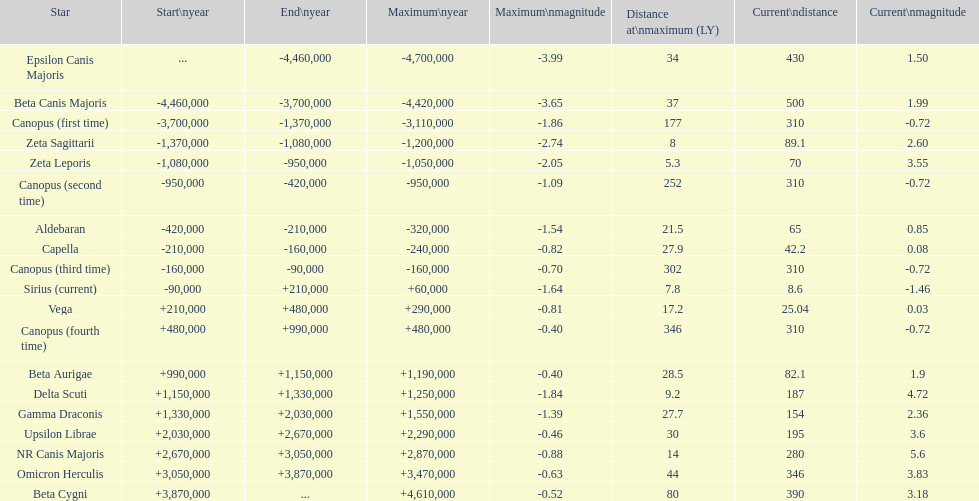What is the number of stars that have a maximum magnitude less than zero? 5. Would you be able to parse every entry in this table? {'header': ['Star', 'Start\\nyear', 'End\\nyear', 'Maximum\\nyear', 'Maximum\\nmagnitude', 'Distance at\\nmaximum (LY)', 'Current\\ndistance', 'Current\\nmagnitude'], 'rows': [['Epsilon Canis Majoris', '...', '-4,460,000', '-4,700,000', '-3.99', '34', '430', '1.50'], ['Beta Canis Majoris', '-4,460,000', '-3,700,000', '-4,420,000', '-3.65', '37', '500', '1.99'], ['Canopus (first time)', '-3,700,000', '-1,370,000', '-3,110,000', '-1.86', '177', '310', '-0.72'], ['Zeta Sagittarii', '-1,370,000', '-1,080,000', '-1,200,000', '-2.74', '8', '89.1', '2.60'], ['Zeta Leporis', '-1,080,000', '-950,000', '-1,050,000', '-2.05', '5.3', '70', '3.55'], ['Canopus (second time)', '-950,000', '-420,000', '-950,000', '-1.09', '252', '310', '-0.72'], ['Aldebaran', '-420,000', '-210,000', '-320,000', '-1.54', '21.5', '65', '0.85'], ['Capella', '-210,000', '-160,000', '-240,000', '-0.82', '27.9', '42.2', '0.08'], ['Canopus (third time)', '-160,000', '-90,000', '-160,000', '-0.70', '302', '310', '-0.72'], ['Sirius (current)', '-90,000', '+210,000', '+60,000', '-1.64', '7.8', '8.6', '-1.46'], ['Vega', '+210,000', '+480,000', '+290,000', '-0.81', '17.2', '25.04', '0.03'], ['Canopus (fourth time)', '+480,000', '+990,000', '+480,000', '-0.40', '346', '310', '-0.72'], ['Beta Aurigae', '+990,000', '+1,150,000', '+1,190,000', '-0.40', '28.5', '82.1', '1.9'], ['Delta Scuti', '+1,150,000', '+1,330,000', '+1,250,000', '-1.84', '9.2', '187', '4.72'], ['Gamma Draconis', '+1,330,000', '+2,030,000', '+1,550,000', '-1.39', '27.7', '154', '2.36'], ['Upsilon Librae', '+2,030,000', '+2,670,000', '+2,290,000', '-0.46', '30', '195', '3.6'], ['NR Canis Majoris', '+2,670,000', '+3,050,000', '+2,870,000', '-0.88', '14', '280', '5.6'], ['Omicron Herculis', '+3,050,000', '+3,870,000', '+3,470,000', '-0.63', '44', '346', '3.83'], ['Beta Cygni', '+3,870,000', '...', '+4,610,000', '-0.52', '80', '390', '3.18']]} 